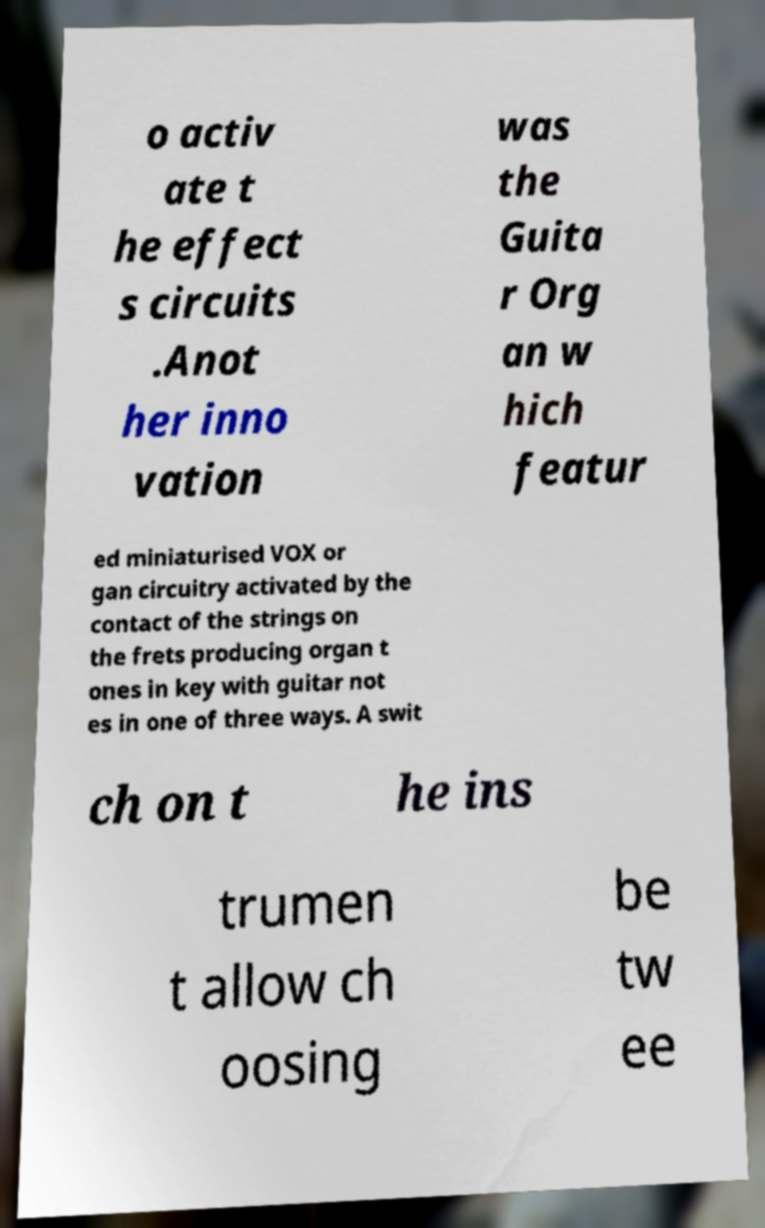I need the written content from this picture converted into text. Can you do that? o activ ate t he effect s circuits .Anot her inno vation was the Guita r Org an w hich featur ed miniaturised VOX or gan circuitry activated by the contact of the strings on the frets producing organ t ones in key with guitar not es in one of three ways. A swit ch on t he ins trumen t allow ch oosing be tw ee 